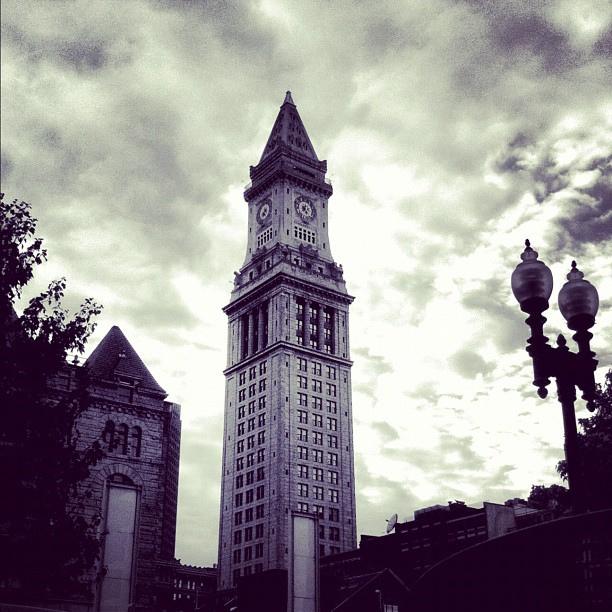Is this a new building?
Quick response, please. No. Could people looking at the tower see what time it is?
Keep it brief. Yes. Is the sun shining in this picture?
Give a very brief answer. No. 